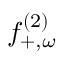<formula> <loc_0><loc_0><loc_500><loc_500>f _ { + , \omega } ^ { ( 2 ) }</formula> 